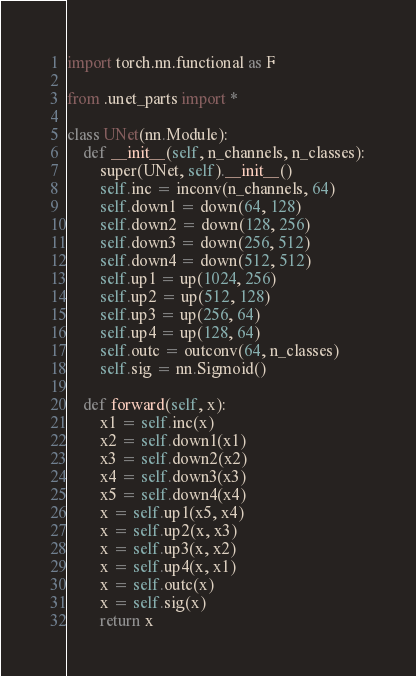Convert code to text. <code><loc_0><loc_0><loc_500><loc_500><_Python_>import torch.nn.functional as F

from .unet_parts import *

class UNet(nn.Module):
    def __init__(self, n_channels, n_classes):
        super(UNet, self).__init__()
        self.inc = inconv(n_channels, 64)
        self.down1 = down(64, 128)
        self.down2 = down(128, 256)
        self.down3 = down(256, 512)
        self.down4 = down(512, 512)
        self.up1 = up(1024, 256)
        self.up2 = up(512, 128)
        self.up3 = up(256, 64)
        self.up4 = up(128, 64)
        self.outc = outconv(64, n_classes)
        self.sig = nn.Sigmoid()

    def forward(self, x):
        x1 = self.inc(x)
        x2 = self.down1(x1)
        x3 = self.down2(x2)
        x4 = self.down3(x3)
        x5 = self.down4(x4)
        x = self.up1(x5, x4)
        x = self.up2(x, x3)
        x = self.up3(x, x2)
        x = self.up4(x, x1)
        x = self.outc(x)
        x = self.sig(x)
        return x
</code> 